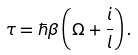Convert formula to latex. <formula><loc_0><loc_0><loc_500><loc_500>\tau = \hbar { \beta } \left ( \Omega + \frac { i } { l } \right ) .</formula> 